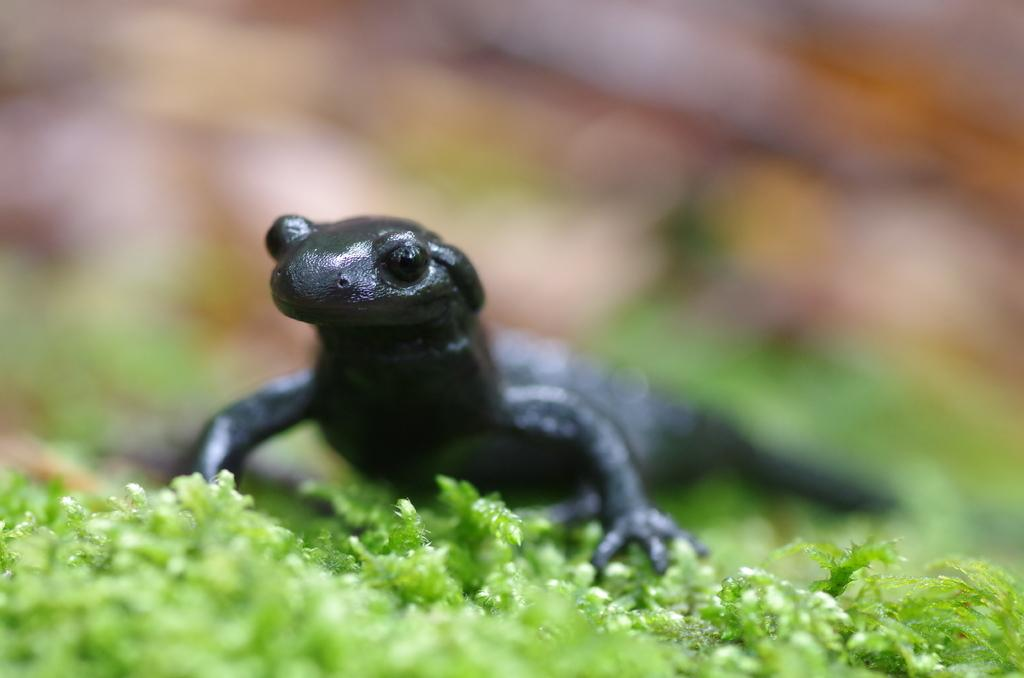What type of living organisms can be seen at the bottom of the image? There are plants at the bottom of the image. What other living organism is present in the image? There is a black color lizard in the image. Can you describe the background of the image? The background of the image is blurred. What type of behavior can be observed in the frogs in the image? There are no frogs present in the image, so their behavior cannot be observed. 